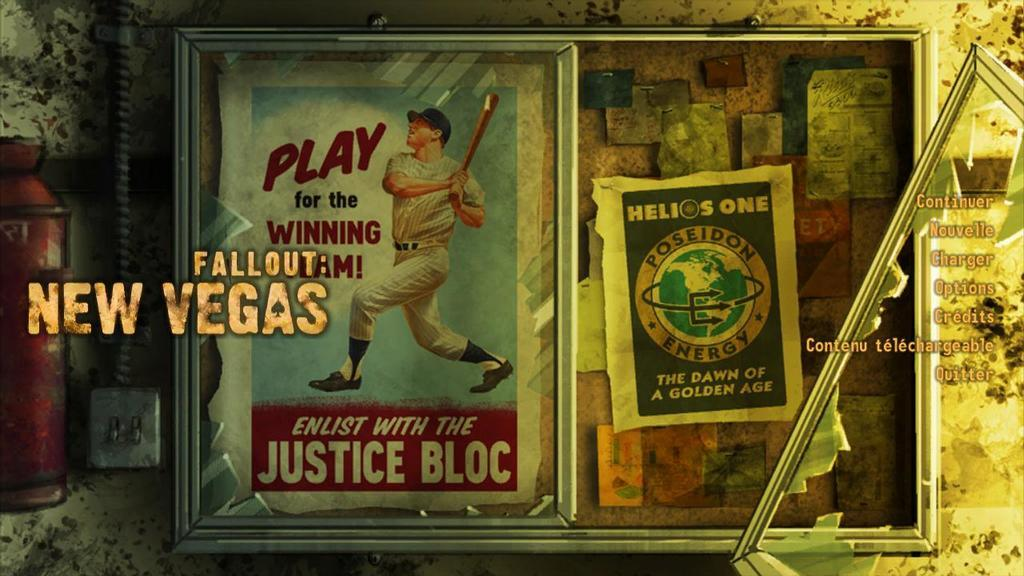<image>
Summarize the visual content of the image. The old poster shown tells us to play for the winning team. 